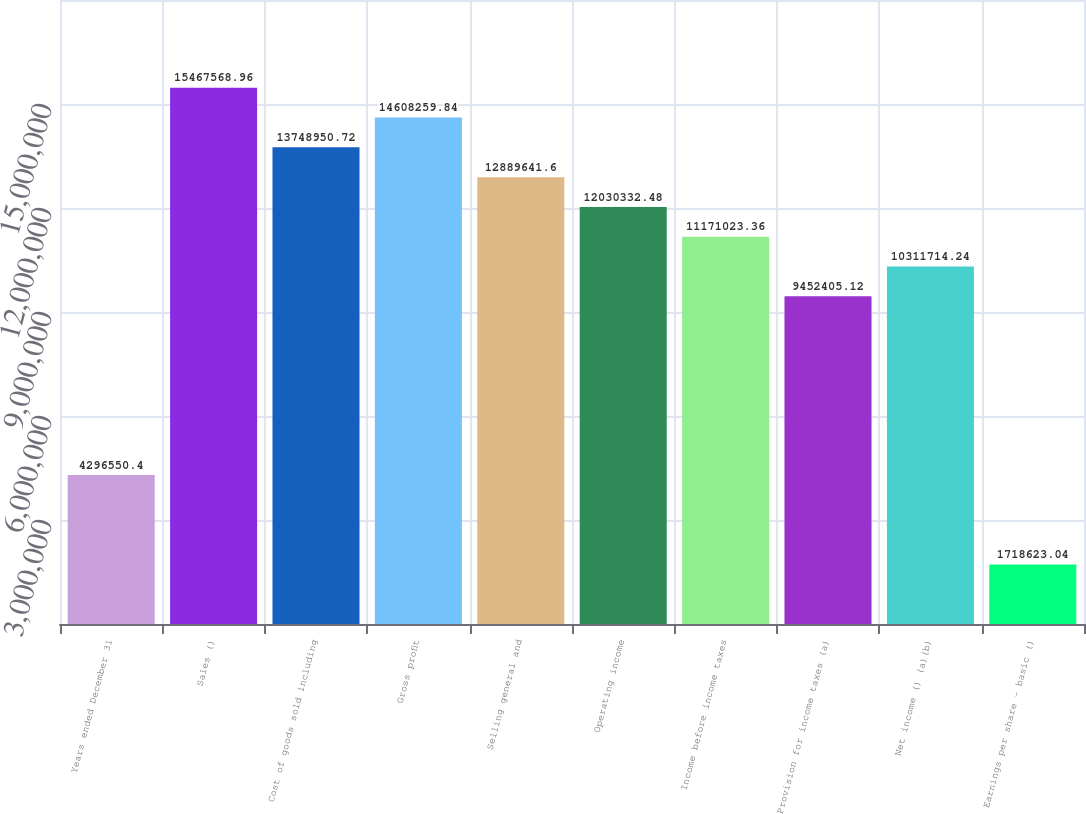<chart> <loc_0><loc_0><loc_500><loc_500><bar_chart><fcel>Years ended December 31<fcel>Sales ()<fcel>Cost of goods sold including<fcel>Gross profit<fcel>Selling general and<fcel>Operating income<fcel>Income before income taxes<fcel>Provision for income taxes (a)<fcel>Net income () (a)(b)<fcel>Earnings per share - basic ()<nl><fcel>4.29655e+06<fcel>1.54676e+07<fcel>1.3749e+07<fcel>1.46083e+07<fcel>1.28896e+07<fcel>1.20303e+07<fcel>1.1171e+07<fcel>9.45241e+06<fcel>1.03117e+07<fcel>1.71862e+06<nl></chart> 